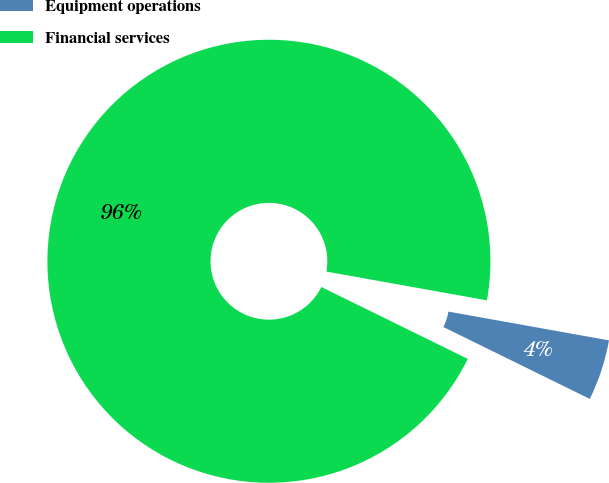Convert chart to OTSL. <chart><loc_0><loc_0><loc_500><loc_500><pie_chart><fcel>Equipment operations<fcel>Financial services<nl><fcel>4.44%<fcel>95.56%<nl></chart> 